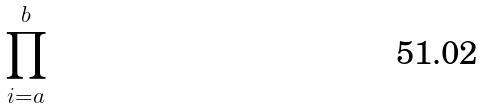Convert formula to latex. <formula><loc_0><loc_0><loc_500><loc_500>\prod _ { i = a } ^ { b }</formula> 